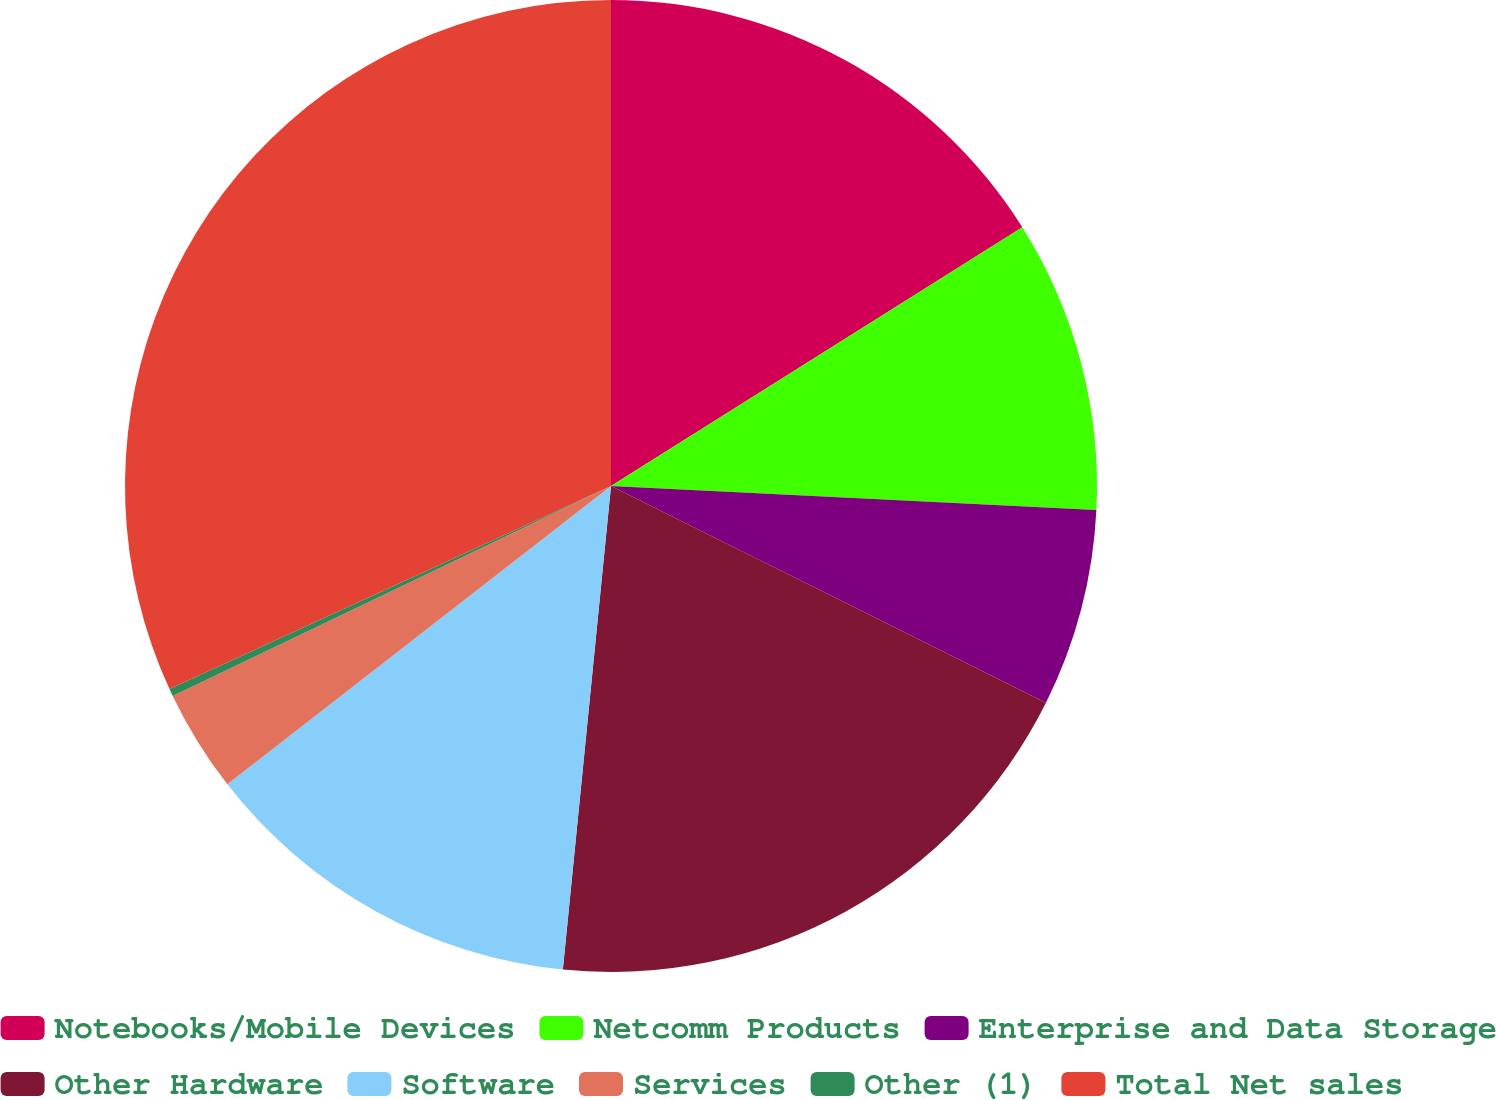Convert chart. <chart><loc_0><loc_0><loc_500><loc_500><pie_chart><fcel>Notebooks/Mobile Devices<fcel>Netcomm Products<fcel>Enterprise and Data Storage<fcel>Other Hardware<fcel>Software<fcel>Services<fcel>Other (1)<fcel>Total Net sales<nl><fcel>16.06%<fcel>9.73%<fcel>6.57%<fcel>19.22%<fcel>12.9%<fcel>3.41%<fcel>0.25%<fcel>31.86%<nl></chart> 